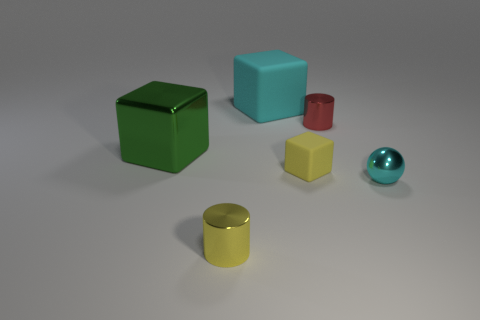The tiny cylinder in front of the tiny cylinder behind the large metallic block is made of what material?
Your answer should be very brief. Metal. How many objects are either green metallic blocks or small cyan metallic balls?
Make the answer very short. 2. What is the size of the object that is the same color as the big rubber cube?
Give a very brief answer. Small. Is the number of tiny gray matte things less than the number of green shiny things?
Make the answer very short. Yes. There is a red cylinder that is made of the same material as the big green cube; what size is it?
Give a very brief answer. Small. The cyan matte cube is what size?
Offer a very short reply. Large. What shape is the green thing?
Your response must be concise. Cube. There is a tiny thing that is to the left of the yellow block; is its color the same as the tiny rubber object?
Ensure brevity in your answer.  Yes. There is a green metal thing that is the same shape as the large cyan object; what is its size?
Ensure brevity in your answer.  Large. There is a cyan object in front of the shiny cylinder that is behind the cyan metallic object; are there any shiny cylinders behind it?
Keep it short and to the point. Yes. 